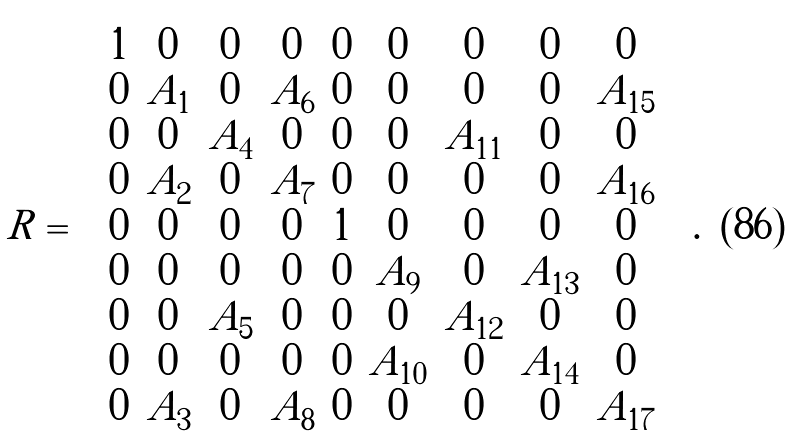<formula> <loc_0><loc_0><loc_500><loc_500>R = \left ( \begin{array} { c c c c c c c c c } 1 & 0 & 0 & 0 & 0 & 0 & 0 & 0 & 0 \\ 0 & A _ { 1 } & 0 & A _ { 6 } & 0 & 0 & 0 & 0 & A _ { 1 5 } \\ 0 & 0 & A _ { 4 } & 0 & 0 & 0 & A _ { 1 1 } & 0 & 0 \\ 0 & A _ { 2 } & 0 & A _ { 7 } & 0 & 0 & 0 & 0 & A _ { 1 6 } \\ 0 & 0 & 0 & 0 & 1 & 0 & 0 & 0 & 0 \\ 0 & 0 & 0 & 0 & 0 & A _ { 9 } & 0 & A _ { 1 3 } & 0 \\ 0 & 0 & A _ { 5 } & 0 & 0 & 0 & A _ { 1 2 } & 0 & 0 \\ 0 & 0 & 0 & 0 & 0 & A _ { 1 0 } & 0 & A _ { 1 4 } & 0 \\ 0 & A _ { 3 } & 0 & A _ { 8 } & 0 & 0 & 0 & 0 & A _ { 1 7 } \end{array} \right ) .</formula> 